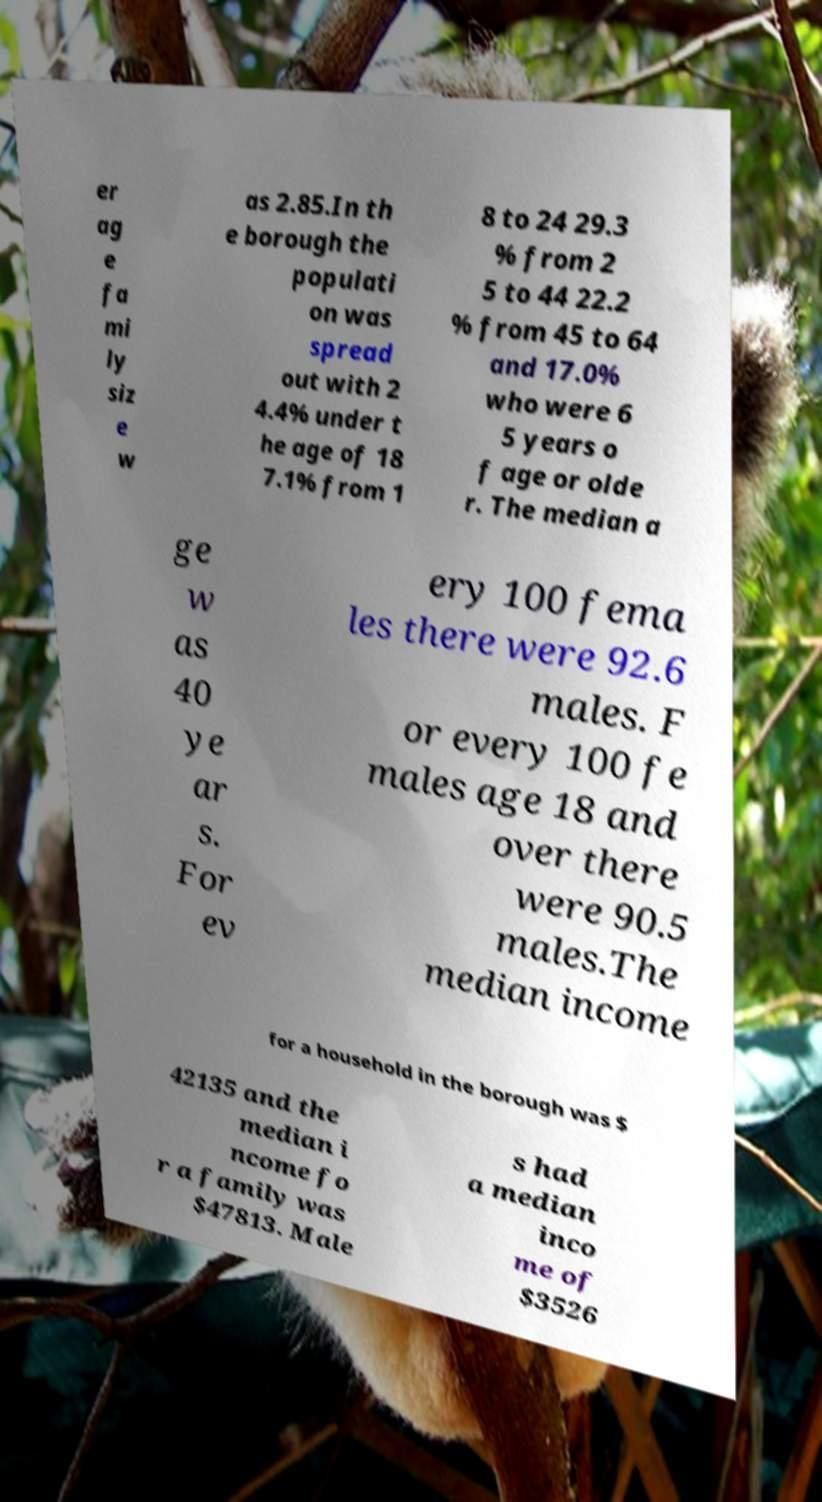For documentation purposes, I need the text within this image transcribed. Could you provide that? er ag e fa mi ly siz e w as 2.85.In th e borough the populati on was spread out with 2 4.4% under t he age of 18 7.1% from 1 8 to 24 29.3 % from 2 5 to 44 22.2 % from 45 to 64 and 17.0% who were 6 5 years o f age or olde r. The median a ge w as 40 ye ar s. For ev ery 100 fema les there were 92.6 males. F or every 100 fe males age 18 and over there were 90.5 males.The median income for a household in the borough was $ 42135 and the median i ncome fo r a family was $47813. Male s had a median inco me of $3526 